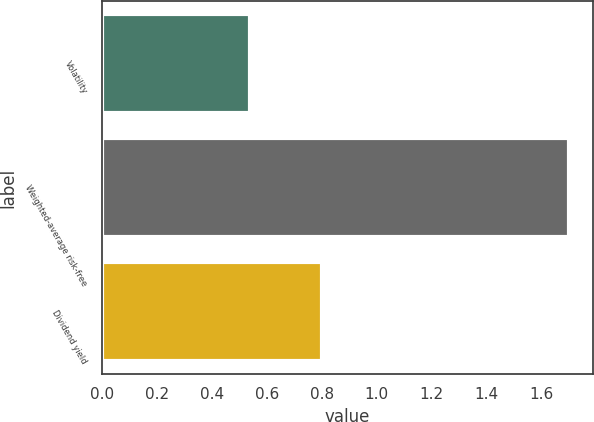Convert chart to OTSL. <chart><loc_0><loc_0><loc_500><loc_500><bar_chart><fcel>Volatility<fcel>Weighted-average risk-free<fcel>Dividend yield<nl><fcel>0.54<fcel>1.7<fcel>0.8<nl></chart> 